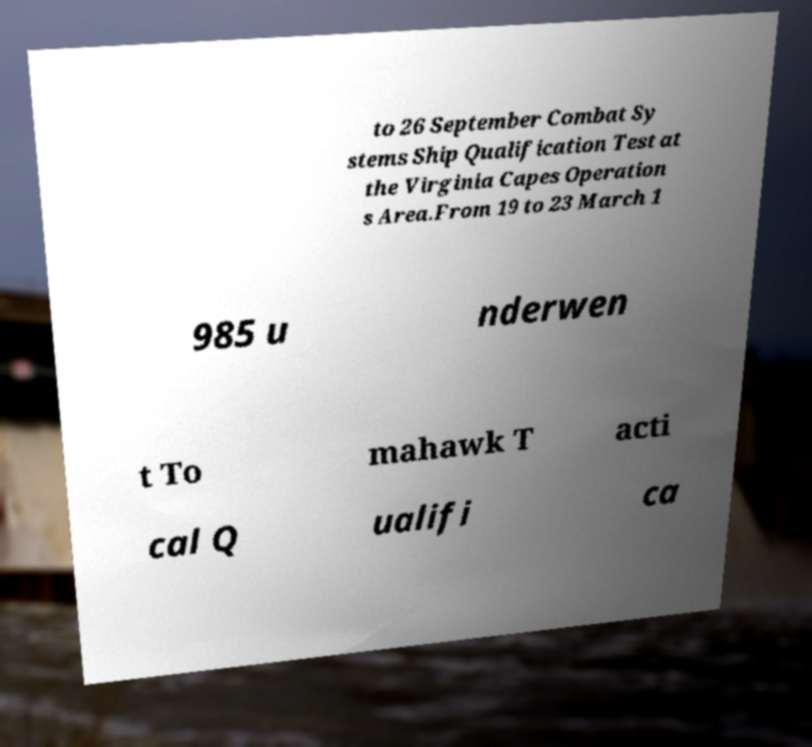Could you extract and type out the text from this image? to 26 September Combat Sy stems Ship Qualification Test at the Virginia Capes Operation s Area.From 19 to 23 March 1 985 u nderwen t To mahawk T acti cal Q ualifi ca 